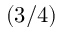<formula> <loc_0><loc_0><loc_500><loc_500>( 3 / 4 )</formula> 